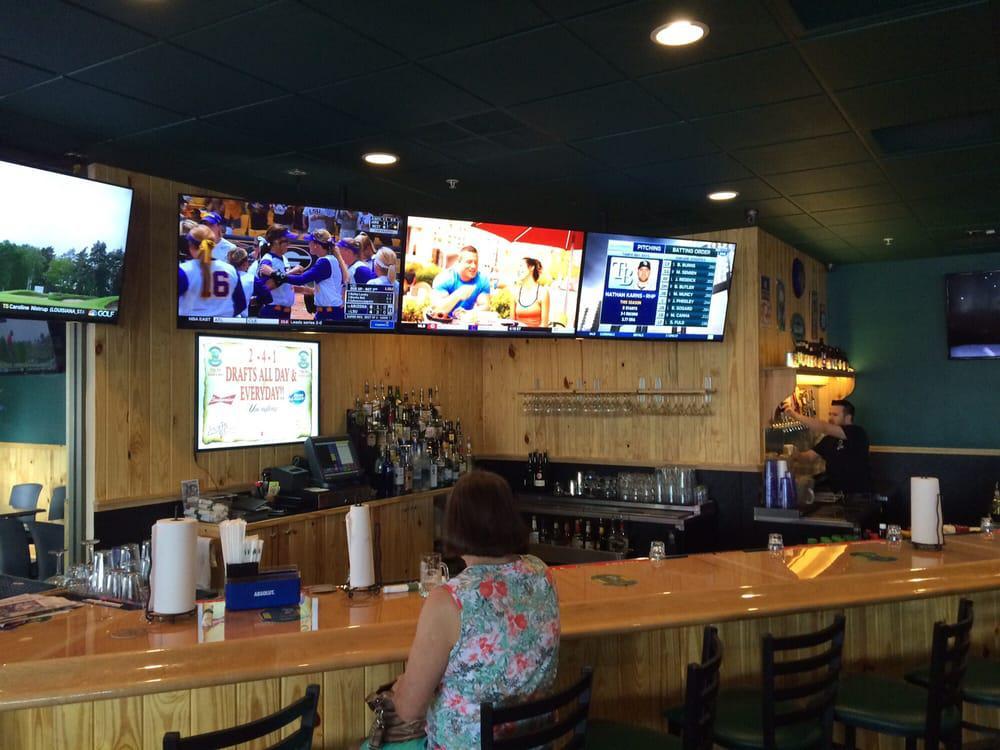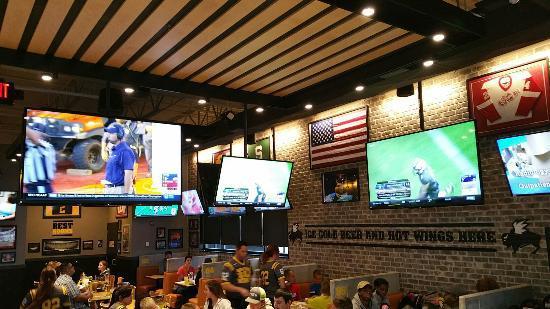The first image is the image on the left, the second image is the image on the right. For the images displayed, is the sentence "A bar image includes no more than two customers in the foreground, sitting with back to the camera watching TV screens." factually correct? Answer yes or no. Yes. 